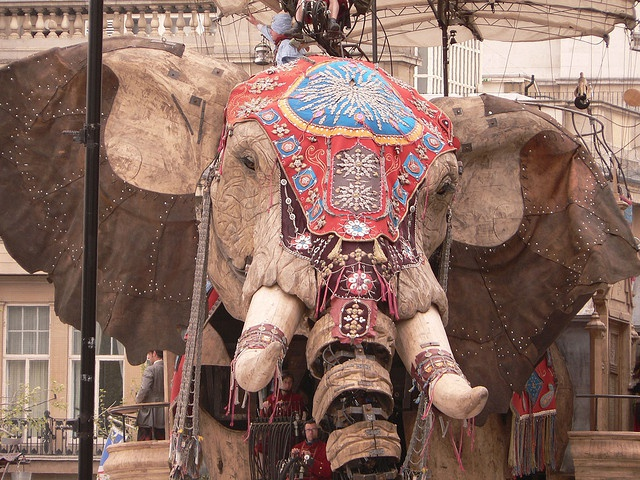Describe the objects in this image and their specific colors. I can see elephant in lightgray, maroon, gray, tan, and brown tones, umbrella in lightgray, tan, and gray tones, people in lightgray, gray, and black tones, people in lightgray, maroon, black, and brown tones, and people in lightgray, darkgray, gray, and brown tones in this image. 